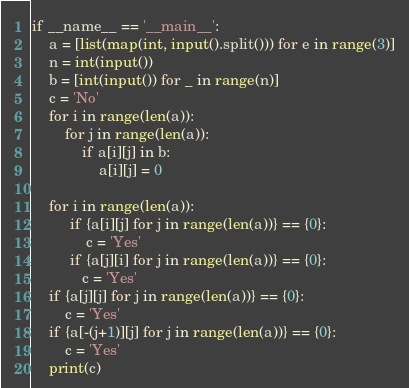Convert code to text. <code><loc_0><loc_0><loc_500><loc_500><_Python_>if __name__ == '__main__':
    a = [list(map(int, input().split())) for e in range(3)]
    n = int(input())
    b = [int(input()) for _ in range(n)]
    c = 'No'
    for i in range(len(a)):
        for j in range(len(a)):
            if a[i][j] in b:
                a[i][j] = 0

    for i in range(len(a)):
         if {a[i][j] for j in range(len(a))} == {0}:
             c = 'Yes'
         if {a[j][i] for j in range(len(a))} == {0}:
            c = 'Yes'
    if {a[j][j] for j in range(len(a))} == {0}:
        c = 'Yes'
    if {a[-(j+1)][j] for j in range(len(a))} == {0}:
        c = 'Yes'
    print(c)</code> 